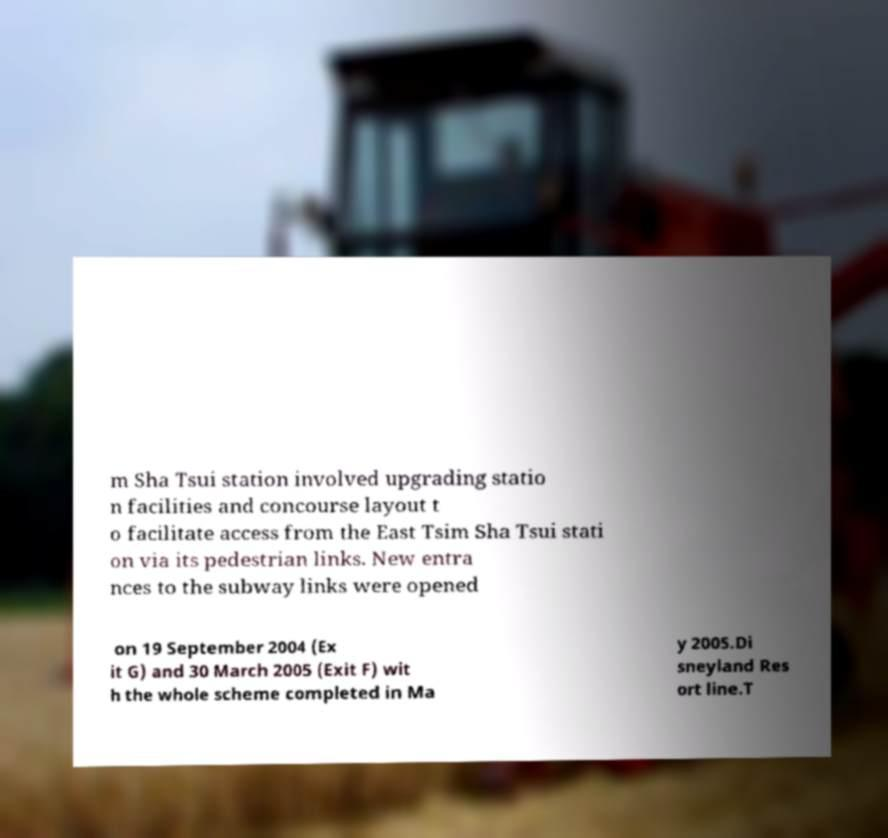There's text embedded in this image that I need extracted. Can you transcribe it verbatim? m Sha Tsui station involved upgrading statio n facilities and concourse layout t o facilitate access from the East Tsim Sha Tsui stati on via its pedestrian links. New entra nces to the subway links were opened on 19 September 2004 (Ex it G) and 30 March 2005 (Exit F) wit h the whole scheme completed in Ma y 2005.Di sneyland Res ort line.T 